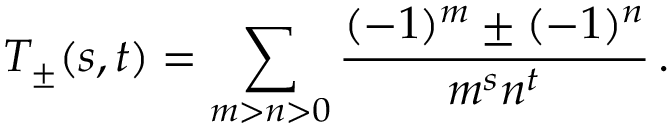<formula> <loc_0><loc_0><loc_500><loc_500>T _ { \pm } ( s , t ) = \sum _ { m > n > 0 } \frac { ( - 1 ) ^ { m } \pm ( - 1 ) ^ { n } } { m ^ { s } n ^ { t } } \, .</formula> 